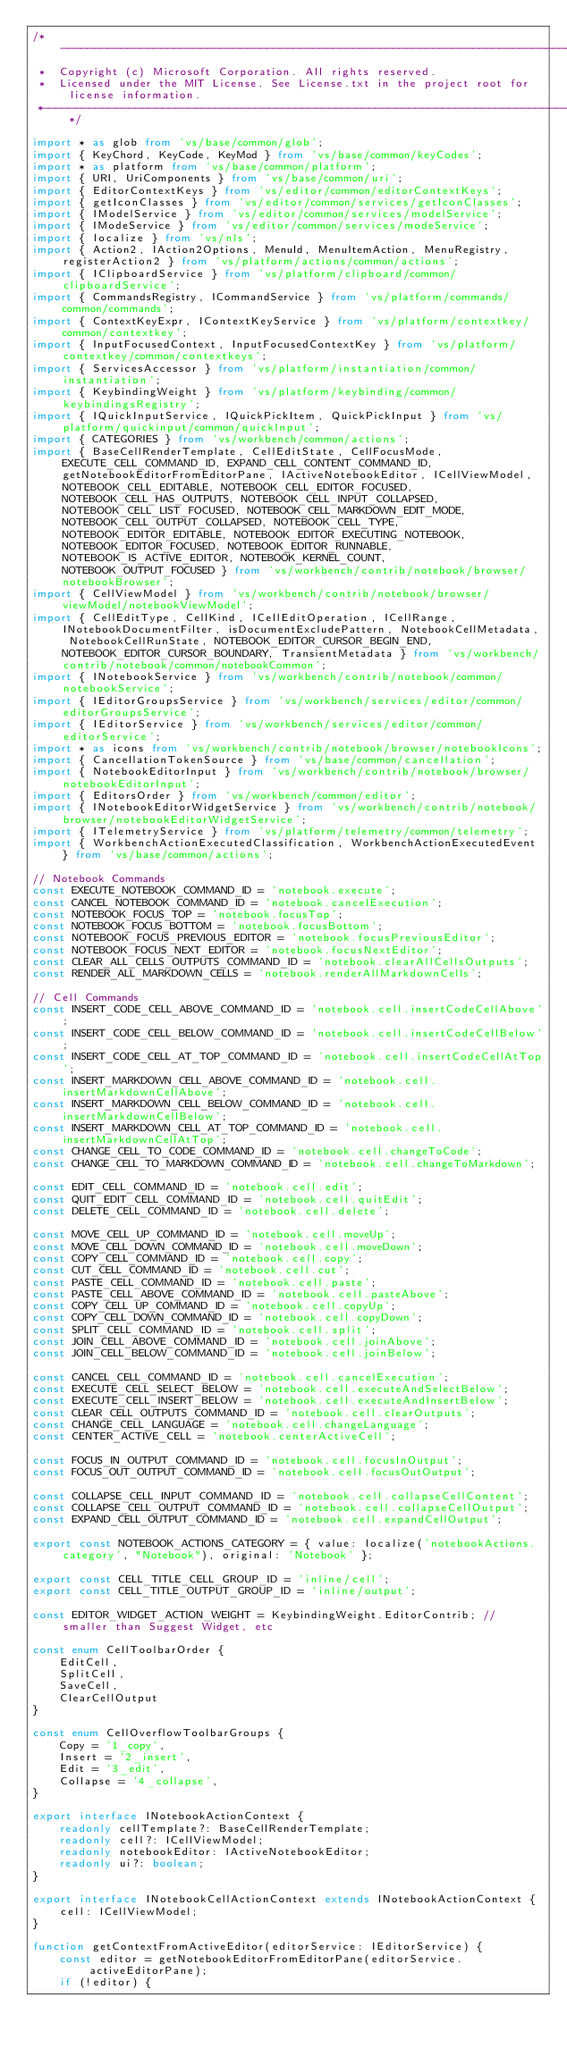<code> <loc_0><loc_0><loc_500><loc_500><_TypeScript_>/*---------------------------------------------------------------------------------------------
 *  Copyright (c) Microsoft Corporation. All rights reserved.
 *  Licensed under the MIT License. See License.txt in the project root for license information.
 *--------------------------------------------------------------------------------------------*/

import * as glob from 'vs/base/common/glob';
import { KeyChord, KeyCode, KeyMod } from 'vs/base/common/keyCodes';
import * as platform from 'vs/base/common/platform';
import { URI, UriComponents } from 'vs/base/common/uri';
import { EditorContextKeys } from 'vs/editor/common/editorContextKeys';
import { getIconClasses } from 'vs/editor/common/services/getIconClasses';
import { IModelService } from 'vs/editor/common/services/modelService';
import { IModeService } from 'vs/editor/common/services/modeService';
import { localize } from 'vs/nls';
import { Action2, IAction2Options, MenuId, MenuItemAction, MenuRegistry, registerAction2 } from 'vs/platform/actions/common/actions';
import { IClipboardService } from 'vs/platform/clipboard/common/clipboardService';
import { CommandsRegistry, ICommandService } from 'vs/platform/commands/common/commands';
import { ContextKeyExpr, IContextKeyService } from 'vs/platform/contextkey/common/contextkey';
import { InputFocusedContext, InputFocusedContextKey } from 'vs/platform/contextkey/common/contextkeys';
import { ServicesAccessor } from 'vs/platform/instantiation/common/instantiation';
import { KeybindingWeight } from 'vs/platform/keybinding/common/keybindingsRegistry';
import { IQuickInputService, IQuickPickItem, QuickPickInput } from 'vs/platform/quickinput/common/quickInput';
import { CATEGORIES } from 'vs/workbench/common/actions';
import { BaseCellRenderTemplate, CellEditState, CellFocusMode, EXECUTE_CELL_COMMAND_ID, EXPAND_CELL_CONTENT_COMMAND_ID, getNotebookEditorFromEditorPane, IActiveNotebookEditor, ICellViewModel, NOTEBOOK_CELL_EDITABLE, NOTEBOOK_CELL_EDITOR_FOCUSED, NOTEBOOK_CELL_HAS_OUTPUTS, NOTEBOOK_CELL_INPUT_COLLAPSED, NOTEBOOK_CELL_LIST_FOCUSED, NOTEBOOK_CELL_MARKDOWN_EDIT_MODE, NOTEBOOK_CELL_OUTPUT_COLLAPSED, NOTEBOOK_CELL_TYPE, NOTEBOOK_EDITOR_EDITABLE, NOTEBOOK_EDITOR_EXECUTING_NOTEBOOK, NOTEBOOK_EDITOR_FOCUSED, NOTEBOOK_EDITOR_RUNNABLE, NOTEBOOK_IS_ACTIVE_EDITOR, NOTEBOOK_KERNEL_COUNT, NOTEBOOK_OUTPUT_FOCUSED } from 'vs/workbench/contrib/notebook/browser/notebookBrowser';
import { CellViewModel } from 'vs/workbench/contrib/notebook/browser/viewModel/notebookViewModel';
import { CellEditType, CellKind, ICellEditOperation, ICellRange, INotebookDocumentFilter, isDocumentExcludePattern, NotebookCellMetadata, NotebookCellRunState, NOTEBOOK_EDITOR_CURSOR_BEGIN_END, NOTEBOOK_EDITOR_CURSOR_BOUNDARY, TransientMetadata } from 'vs/workbench/contrib/notebook/common/notebookCommon';
import { INotebookService } from 'vs/workbench/contrib/notebook/common/notebookService';
import { IEditorGroupsService } from 'vs/workbench/services/editor/common/editorGroupsService';
import { IEditorService } from 'vs/workbench/services/editor/common/editorService';
import * as icons from 'vs/workbench/contrib/notebook/browser/notebookIcons';
import { CancellationTokenSource } from 'vs/base/common/cancellation';
import { NotebookEditorInput } from 'vs/workbench/contrib/notebook/browser/notebookEditorInput';
import { EditorsOrder } from 'vs/workbench/common/editor';
import { INotebookEditorWidgetService } from 'vs/workbench/contrib/notebook/browser/notebookEditorWidgetService';
import { ITelemetryService } from 'vs/platform/telemetry/common/telemetry';
import { WorkbenchActionExecutedClassification, WorkbenchActionExecutedEvent } from 'vs/base/common/actions';

// Notebook Commands
const EXECUTE_NOTEBOOK_COMMAND_ID = 'notebook.execute';
const CANCEL_NOTEBOOK_COMMAND_ID = 'notebook.cancelExecution';
const NOTEBOOK_FOCUS_TOP = 'notebook.focusTop';
const NOTEBOOK_FOCUS_BOTTOM = 'notebook.focusBottom';
const NOTEBOOK_FOCUS_PREVIOUS_EDITOR = 'notebook.focusPreviousEditor';
const NOTEBOOK_FOCUS_NEXT_EDITOR = 'notebook.focusNextEditor';
const CLEAR_ALL_CELLS_OUTPUTS_COMMAND_ID = 'notebook.clearAllCellsOutputs';
const RENDER_ALL_MARKDOWN_CELLS = 'notebook.renderAllMarkdownCells';

// Cell Commands
const INSERT_CODE_CELL_ABOVE_COMMAND_ID = 'notebook.cell.insertCodeCellAbove';
const INSERT_CODE_CELL_BELOW_COMMAND_ID = 'notebook.cell.insertCodeCellBelow';
const INSERT_CODE_CELL_AT_TOP_COMMAND_ID = 'notebook.cell.insertCodeCellAtTop';
const INSERT_MARKDOWN_CELL_ABOVE_COMMAND_ID = 'notebook.cell.insertMarkdownCellAbove';
const INSERT_MARKDOWN_CELL_BELOW_COMMAND_ID = 'notebook.cell.insertMarkdownCellBelow';
const INSERT_MARKDOWN_CELL_AT_TOP_COMMAND_ID = 'notebook.cell.insertMarkdownCellAtTop';
const CHANGE_CELL_TO_CODE_COMMAND_ID = 'notebook.cell.changeToCode';
const CHANGE_CELL_TO_MARKDOWN_COMMAND_ID = 'notebook.cell.changeToMarkdown';

const EDIT_CELL_COMMAND_ID = 'notebook.cell.edit';
const QUIT_EDIT_CELL_COMMAND_ID = 'notebook.cell.quitEdit';
const DELETE_CELL_COMMAND_ID = 'notebook.cell.delete';

const MOVE_CELL_UP_COMMAND_ID = 'notebook.cell.moveUp';
const MOVE_CELL_DOWN_COMMAND_ID = 'notebook.cell.moveDown';
const COPY_CELL_COMMAND_ID = 'notebook.cell.copy';
const CUT_CELL_COMMAND_ID = 'notebook.cell.cut';
const PASTE_CELL_COMMAND_ID = 'notebook.cell.paste';
const PASTE_CELL_ABOVE_COMMAND_ID = 'notebook.cell.pasteAbove';
const COPY_CELL_UP_COMMAND_ID = 'notebook.cell.copyUp';
const COPY_CELL_DOWN_COMMAND_ID = 'notebook.cell.copyDown';
const SPLIT_CELL_COMMAND_ID = 'notebook.cell.split';
const JOIN_CELL_ABOVE_COMMAND_ID = 'notebook.cell.joinAbove';
const JOIN_CELL_BELOW_COMMAND_ID = 'notebook.cell.joinBelow';

const CANCEL_CELL_COMMAND_ID = 'notebook.cell.cancelExecution';
const EXECUTE_CELL_SELECT_BELOW = 'notebook.cell.executeAndSelectBelow';
const EXECUTE_CELL_INSERT_BELOW = 'notebook.cell.executeAndInsertBelow';
const CLEAR_CELL_OUTPUTS_COMMAND_ID = 'notebook.cell.clearOutputs';
const CHANGE_CELL_LANGUAGE = 'notebook.cell.changeLanguage';
const CENTER_ACTIVE_CELL = 'notebook.centerActiveCell';

const FOCUS_IN_OUTPUT_COMMAND_ID = 'notebook.cell.focusInOutput';
const FOCUS_OUT_OUTPUT_COMMAND_ID = 'notebook.cell.focusOutOutput';

const COLLAPSE_CELL_INPUT_COMMAND_ID = 'notebook.cell.collapseCellContent';
const COLLAPSE_CELL_OUTPUT_COMMAND_ID = 'notebook.cell.collapseCellOutput';
const EXPAND_CELL_OUTPUT_COMMAND_ID = 'notebook.cell.expandCellOutput';

export const NOTEBOOK_ACTIONS_CATEGORY = { value: localize('notebookActions.category', "Notebook"), original: 'Notebook' };

export const CELL_TITLE_CELL_GROUP_ID = 'inline/cell';
export const CELL_TITLE_OUTPUT_GROUP_ID = 'inline/output';

const EDITOR_WIDGET_ACTION_WEIGHT = KeybindingWeight.EditorContrib; // smaller than Suggest Widget, etc

const enum CellToolbarOrder {
	EditCell,
	SplitCell,
	SaveCell,
	ClearCellOutput
}

const enum CellOverflowToolbarGroups {
	Copy = '1_copy',
	Insert = '2_insert',
	Edit = '3_edit',
	Collapse = '4_collapse',
}

export interface INotebookActionContext {
	readonly cellTemplate?: BaseCellRenderTemplate;
	readonly cell?: ICellViewModel;
	readonly notebookEditor: IActiveNotebookEditor;
	readonly ui?: boolean;
}

export interface INotebookCellActionContext extends INotebookActionContext {
	cell: ICellViewModel;
}

function getContextFromActiveEditor(editorService: IEditorService) {
	const editor = getNotebookEditorFromEditorPane(editorService.activeEditorPane);
	if (!editor) {</code> 